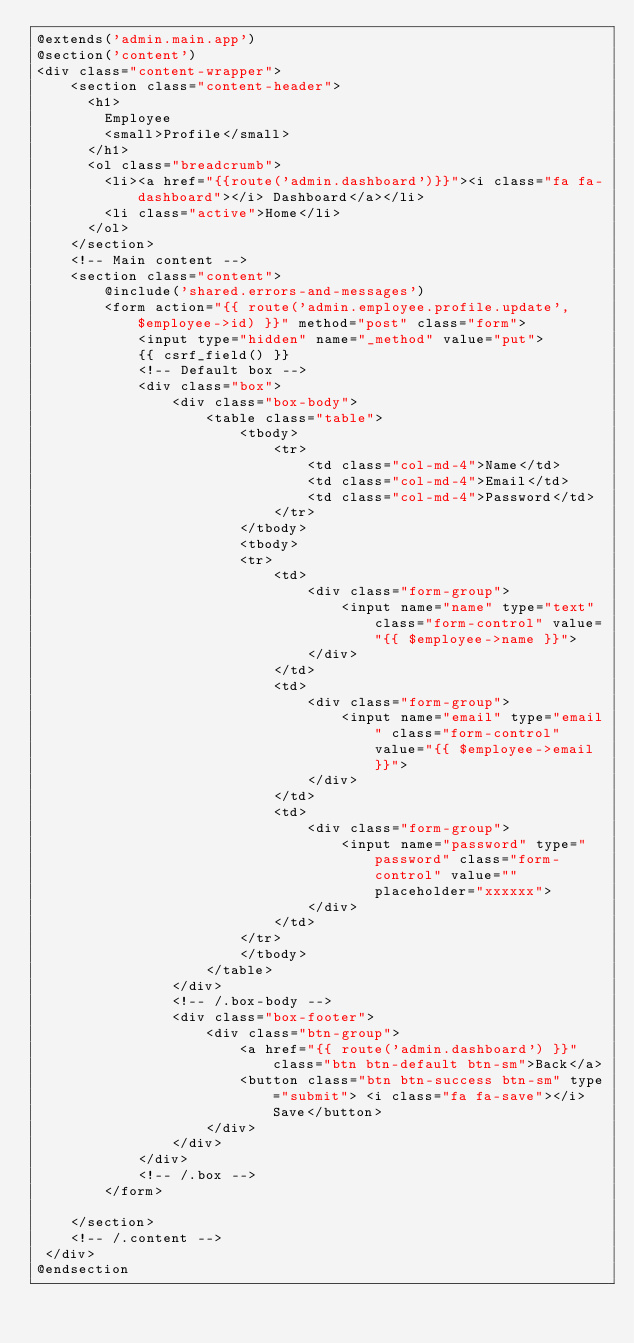Convert code to text. <code><loc_0><loc_0><loc_500><loc_500><_PHP_>@extends('admin.main.app')
@section('content')
<div class="content-wrapper">
    <section class="content-header">
      <h1>
        Employee
        <small>Profile</small>
      </h1>
      <ol class="breadcrumb">
        <li><a href="{{route('admin.dashboard')}}"><i class="fa fa-dashboard"></i> Dashboard</a></li>
        <li class="active">Home</li>
      </ol>
    </section>
    <!-- Main content -->
    <section class="content">
        @include('shared.errors-and-messages')
        <form action="{{ route('admin.employee.profile.update', $employee->id) }}" method="post" class="form">
            <input type="hidden" name="_method" value="put">
            {{ csrf_field() }}
            <!-- Default box -->
            <div class="box">
                <div class="box-body">
                    <table class="table">
                        <tbody>
                            <tr>
                                <td class="col-md-4">Name</td>
                                <td class="col-md-4">Email</td>
                                <td class="col-md-4">Password</td>
                            </tr>
                        </tbody>
                        <tbody>
                        <tr>
                            <td>
                                <div class="form-group">
                                    <input name="name" type="text" class="form-control" value="{{ $employee->name }}">
                                </div>
                            </td>
                            <td>
                                <div class="form-group">
                                    <input name="email" type="email" class="form-control" value="{{ $employee->email }}">
                                </div>
                            </td>
                            <td>
                                <div class="form-group">
                                    <input name="password" type="password" class="form-control" value="" placeholder="xxxxxx">
                                </div>
                            </td>
                        </tr>
                        </tbody>
                    </table>
                </div>
                <!-- /.box-body -->
                <div class="box-footer">
                    <div class="btn-group">
                        <a href="{{ route('admin.dashboard') }}" class="btn btn-default btn-sm">Back</a>
                        <button class="btn btn-success btn-sm" type="submit"> <i class="fa fa-save"></i> Save</button>
                    </div>
                </div>
            </div>
            <!-- /.box -->
        </form>

    </section>
    <!-- /.content -->
 </div>
@endsection
</code> 